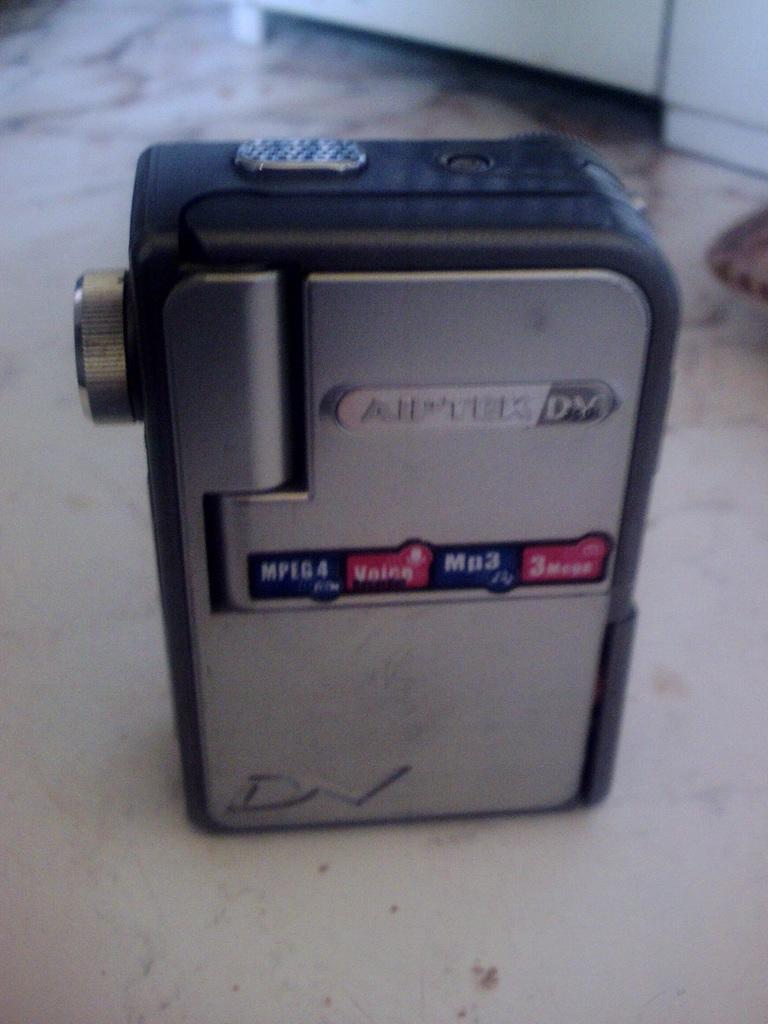In one or two sentences, can you explain what this image depicts? In this image we can see a gadget which is in black and gray color and we can see some text on it and it looks like a video camera. 